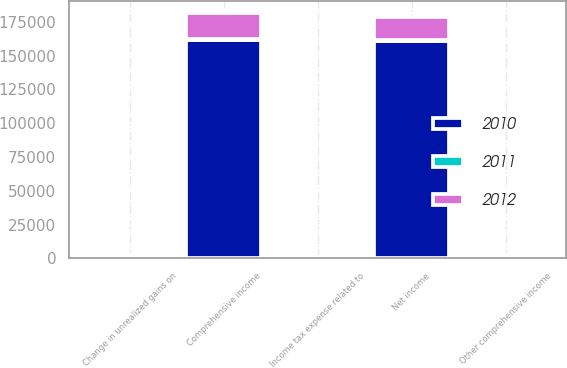<chart> <loc_0><loc_0><loc_500><loc_500><stacked_bar_chart><ecel><fcel>Net income<fcel>Change in unrealized gains on<fcel>Other comprehensive income<fcel>Income tax expense related to<fcel>Comprehensive income<nl><fcel>2012<fcel>17152<fcel>1394<fcel>2213<fcel>538<fcel>19365<nl><fcel>2011<fcel>798<fcel>111<fcel>44<fcel>43<fcel>798<nl><fcel>2010<fcel>160853<fcel>798<fcel>477<fcel>321<fcel>161330<nl></chart> 